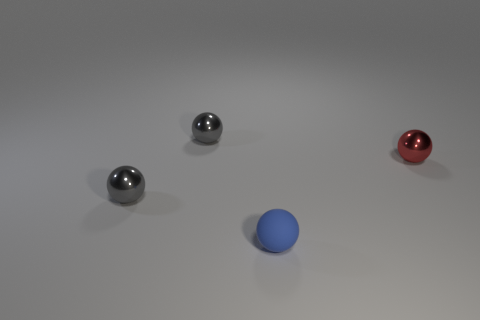What number of other things are there of the same material as the tiny red thing
Make the answer very short. 2. Are the red object and the blue ball left of the tiny red shiny object made of the same material?
Ensure brevity in your answer.  No. There is a blue thing to the left of the red sphere; what is its material?
Provide a succinct answer. Rubber. Are there an equal number of spheres that are on the left side of the red shiny object and small shiny spheres?
Give a very brief answer. Yes. What material is the small blue ball in front of the small metal sphere on the right side of the tiny blue rubber object made of?
Your response must be concise. Rubber. What shape is the thing that is both on the left side of the blue thing and in front of the small red ball?
Keep it short and to the point. Sphere. The blue object that is the same shape as the red object is what size?
Offer a very short reply. Small. Is the number of small gray objects that are in front of the small blue ball less than the number of tiny blue rubber objects?
Keep it short and to the point. Yes. The other small rubber object that is the same shape as the small red thing is what color?
Ensure brevity in your answer.  Blue. There is a shiny thing to the right of the tiny sphere that is behind the red metal object; is there a blue sphere on the right side of it?
Keep it short and to the point. No. 